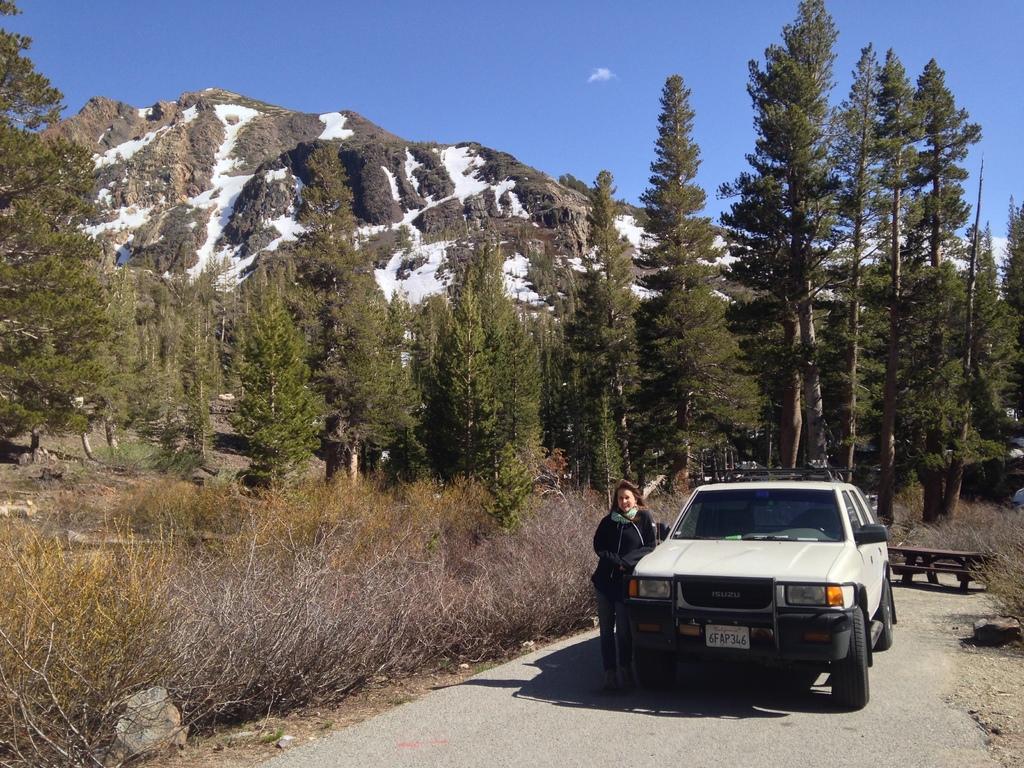Can you describe this image briefly? In this picture there is a woman who is wearing black dress. She is standing near to the car. This car is parked on the road. Behind the car we can see table and benches. In the background we can see mountain, snow, trees, plants and grass. At the top there is a sky and cloud. 